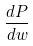Convert formula to latex. <formula><loc_0><loc_0><loc_500><loc_500>\frac { d P } { d w }</formula> 